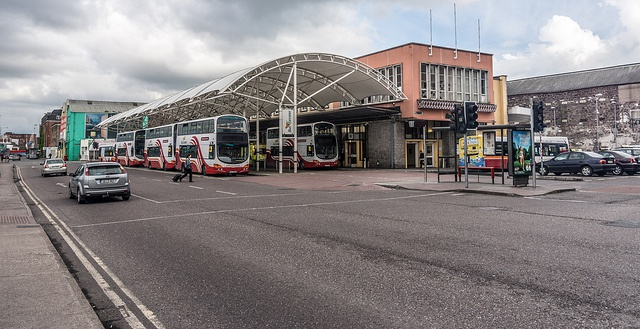Describe the objects in this image and their specific colors. I can see bus in darkgray, black, gray, and lightgray tones, bus in darkgray, black, gray, and maroon tones, car in darkgray, gray, black, and lightgray tones, car in darkgray, black, and gray tones, and bus in darkgray, black, gray, and lightgray tones in this image. 